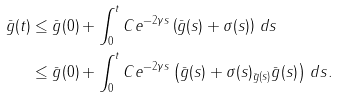<formula> <loc_0><loc_0><loc_500><loc_500>\| \bar { g } ( t ) \| & \leq \| \bar { g } ( 0 ) \| + \int ^ { t } _ { 0 } C e ^ { - 2 \gamma s } \left ( \| \bar { g } ( s ) \| + \| \sigma ( s ) \| \right ) \, d s \\ & \leq \| \bar { g } ( 0 ) \| + \int ^ { t } _ { 0 } C e ^ { - 2 \gamma s } \left ( \| \bar { g } ( s ) \| + \| \sigma ( s ) \| _ { \bar { g } ( s ) } \| \bar { g } ( s ) \| \right ) \, d s .</formula> 